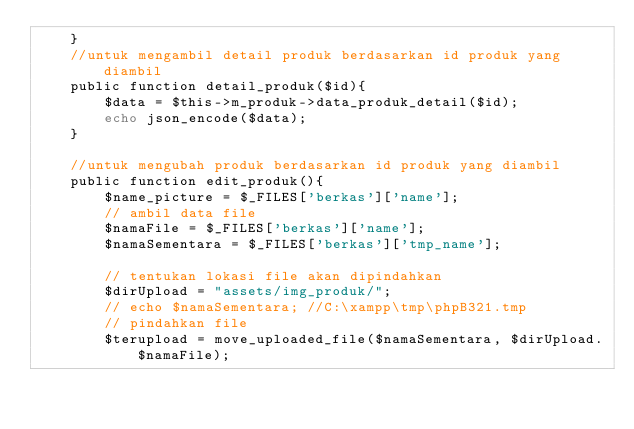Convert code to text. <code><loc_0><loc_0><loc_500><loc_500><_PHP_>	}
	//untuk mengambil detail produk berdasarkan id produk yang diambil
	public function detail_produk($id){
		$data = $this->m_produk->data_produk_detail($id);
		echo json_encode($data);
	}

	//untuk mengubah produk berdasarkan id produk yang diambil
	public function edit_produk(){
		$name_picture = $_FILES['berkas']['name'];
		// ambil data file
		$namaFile = $_FILES['berkas']['name'];
		$namaSementara = $_FILES['berkas']['tmp_name'];

		// tentukan lokasi file akan dipindahkan
		$dirUpload = "assets/img_produk/";
		// echo $namaSementara; //C:\xampp\tmp\phpB321.tmp
		// pindahkan file
		$terupload = move_uploaded_file($namaSementara, $dirUpload.$namaFile);</code> 